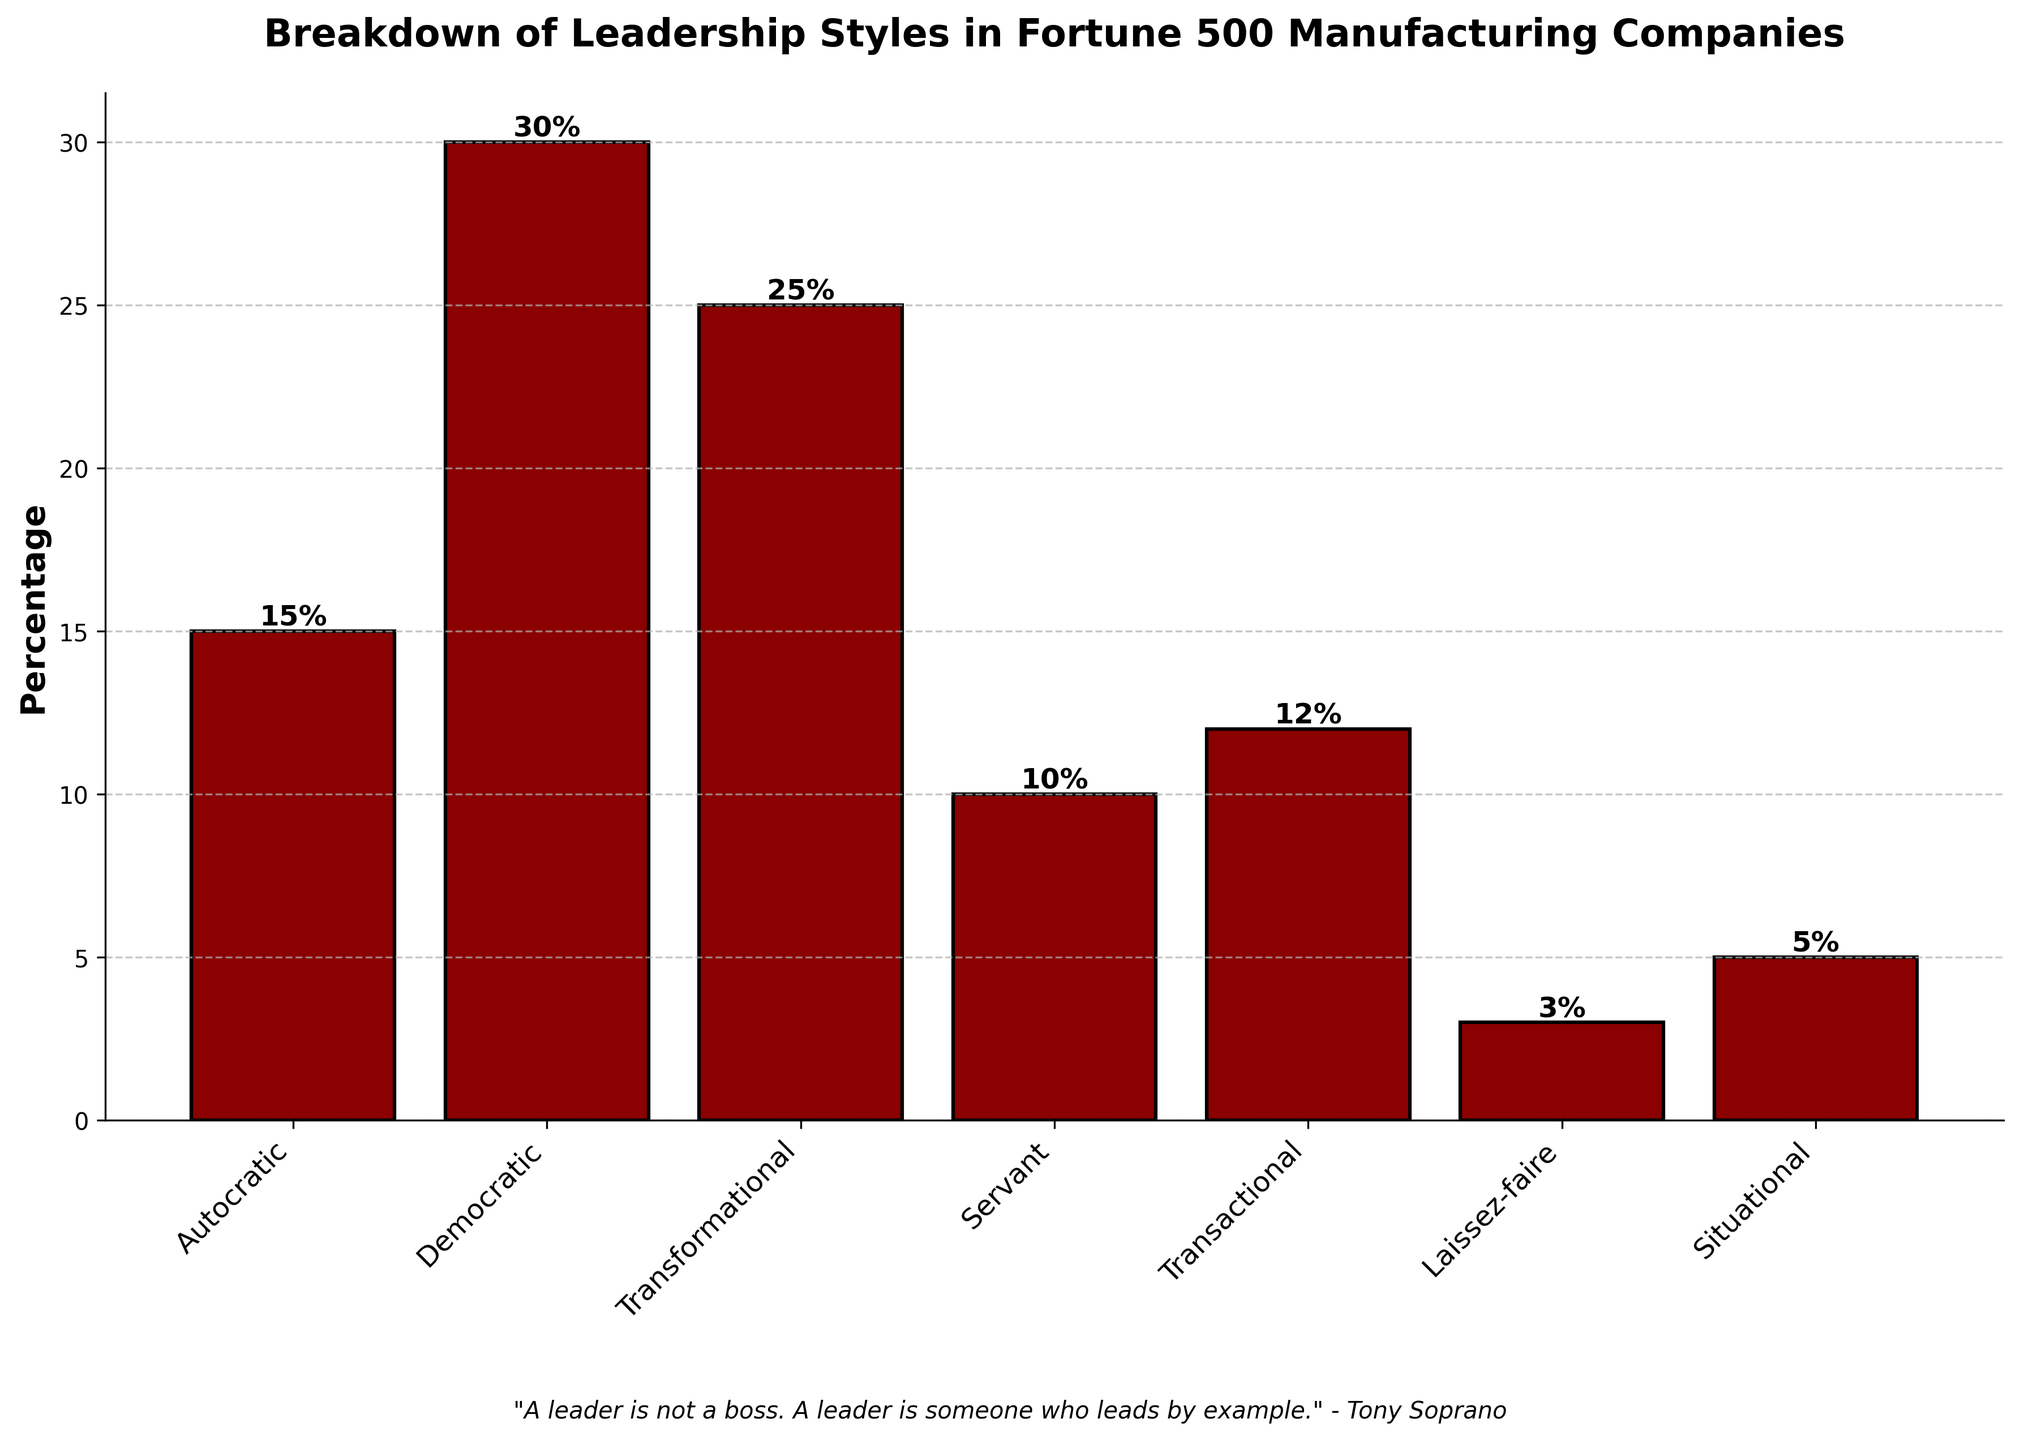What percentage of Fortune 500 manufacturing companies use transformational leadership? The bar labeled "Transformational" shows a height indicating the percentage. It is labeled as 25%. Therefore, the percentage is 25%.
Answer: 25% Compare the percentages of Democratic and Autocratic leadership styles. Which one is higher, and by how much? The percentage for Democratic is 30% and for Autocratic is 15%. To find which is higher and by how much, subtract the percentage of Autocratic from Democratic: 30% - 15% = 15%. Democratic is 15% higher.
Answer: Democratic by 15% What is the total percentage of companies that use either Servant or Situational leadership styles? Add the percentage for Servant (10%) and Situational (5%). The total percentage is 10% + 5% = 15%.
Answer: 15% Which leadership style is the least common? The shortest bar indicates the smallest percentage. The label for this bar reads "Laissez-faire," with a percentage of 3%.
Answer: Laissez-faire How much more common is Democratic leadership than Transactional leadership? Democratic leadership is at 30%, while Transactional leadership is at 12%. Subtract Transactional from Democratic: 30% - 12% = 18%.
Answer: 18% What is the sum of the percentages for Autocratic, Servant, and Situational leadership styles? Add the percentages: 15% for Autocratic, 10% for Servant, and 5% for Situational. Therefore, the sum is 15% + 10% + 5% = 30%.
Answer: 30% Among the leadership styles, which ones have more than 20% representation? Observing the bar heights, "Democratic" has 30% and "Transformational" has 25%. These are the only bars above 20%.
Answer: Democratic and Transformational Which leadership style is represented by a red bar with a label showing '12%'? The bar colored in red with a percentage label of '12%' corresponds to the Transactional leadership style.
Answer: Transactional Calculate the average percentage of Autocratic, Democratic, and Transformational leadership styles. The percentages for Autocratic, Democratic, and Transformational are 15%, 30%, and 25% respectively. To find the average, sum these percentages and divide by 3: (15% + 30% + 25%) / 3 = 70% / 3 ≈ 23.33%.
Answer: 23.33% By looking at the height of the bars, is Transformational leadership closer in percentage to Democratic or to Autocratic leadership? Transformational leadership is at 25%, Democratic is at 30%, and Autocratic is at 15%. The difference between Transformational and Democratic is 30% - 25% = 5%, and the difference between Transformational and Autocratic is 25% - 15% = 10%. Since 5% < 10%, it is closer to Democratic.
Answer: Democratic 